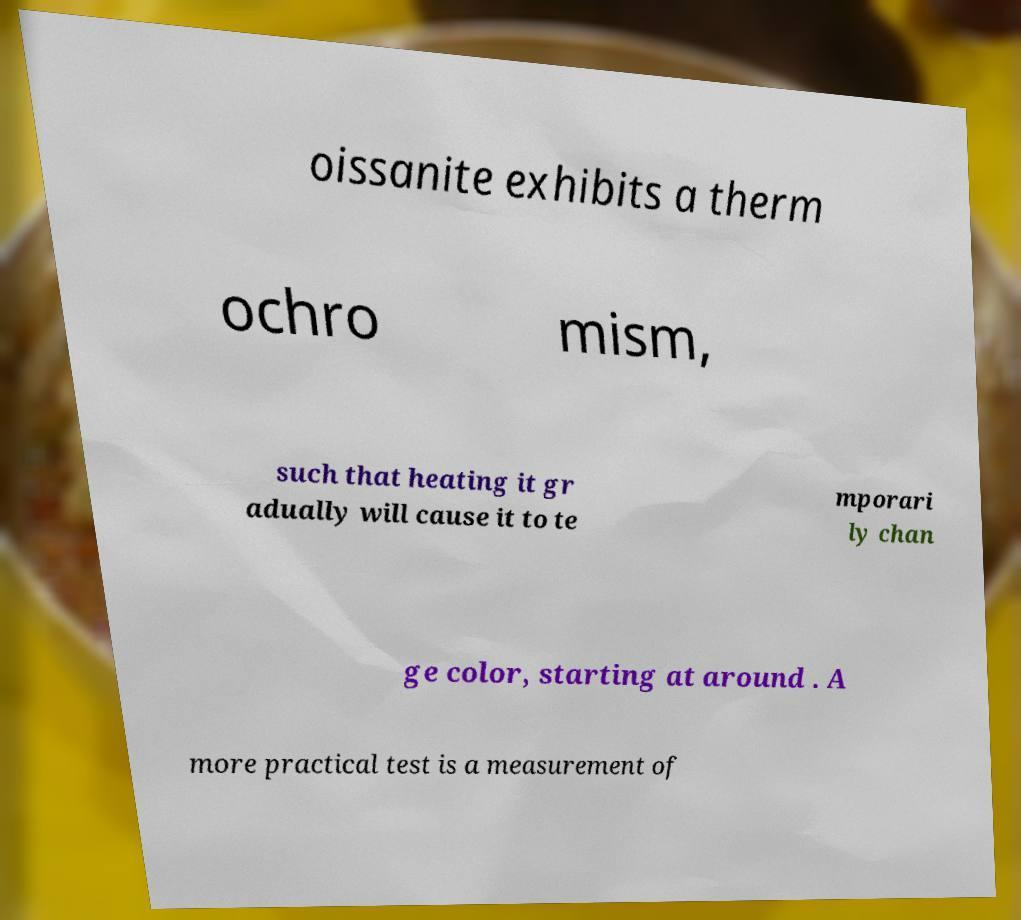Can you read and provide the text displayed in the image?This photo seems to have some interesting text. Can you extract and type it out for me? oissanite exhibits a therm ochro mism, such that heating it gr adually will cause it to te mporari ly chan ge color, starting at around . A more practical test is a measurement of 